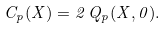Convert formula to latex. <formula><loc_0><loc_0><loc_500><loc_500>C _ { p } ( X ) = 2 \, Q _ { p } ( X , 0 ) .</formula> 